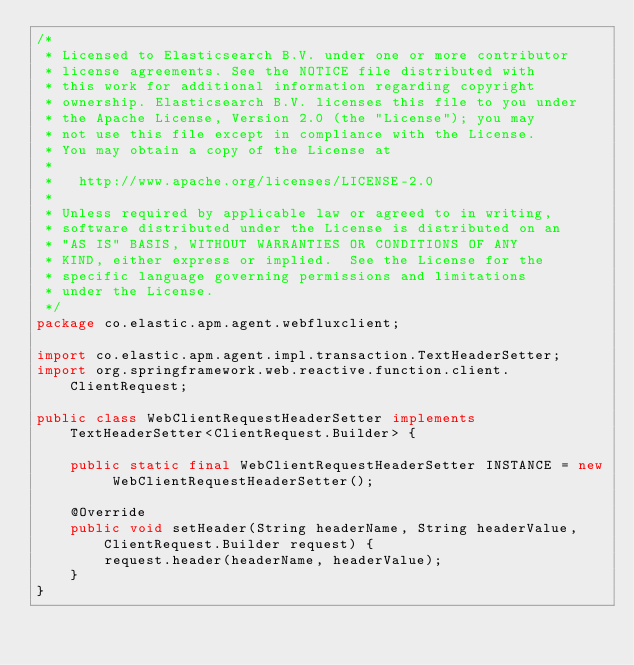<code> <loc_0><loc_0><loc_500><loc_500><_Java_>/*
 * Licensed to Elasticsearch B.V. under one or more contributor
 * license agreements. See the NOTICE file distributed with
 * this work for additional information regarding copyright
 * ownership. Elasticsearch B.V. licenses this file to you under
 * the Apache License, Version 2.0 (the "License"); you may
 * not use this file except in compliance with the License.
 * You may obtain a copy of the License at
 *
 *   http://www.apache.org/licenses/LICENSE-2.0
 *
 * Unless required by applicable law or agreed to in writing,
 * software distributed under the License is distributed on an
 * "AS IS" BASIS, WITHOUT WARRANTIES OR CONDITIONS OF ANY
 * KIND, either express or implied.  See the License for the
 * specific language governing permissions and limitations
 * under the License.
 */
package co.elastic.apm.agent.webfluxclient;

import co.elastic.apm.agent.impl.transaction.TextHeaderSetter;
import org.springframework.web.reactive.function.client.ClientRequest;

public class WebClientRequestHeaderSetter implements TextHeaderSetter<ClientRequest.Builder> {

    public static final WebClientRequestHeaderSetter INSTANCE = new WebClientRequestHeaderSetter();

    @Override
    public void setHeader(String headerName, String headerValue, ClientRequest.Builder request) {
        request.header(headerName, headerValue);
    }
}
</code> 